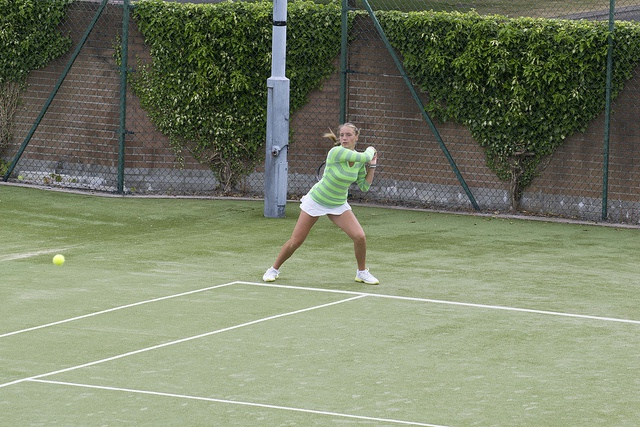Describe the objects in this image and their specific colors. I can see people in darkgreen, lightgray, darkgray, gray, and tan tones, tennis racket in darkgreen, gray, black, and darkgray tones, and sports ball in darkgreen, khaki, and lightyellow tones in this image. 